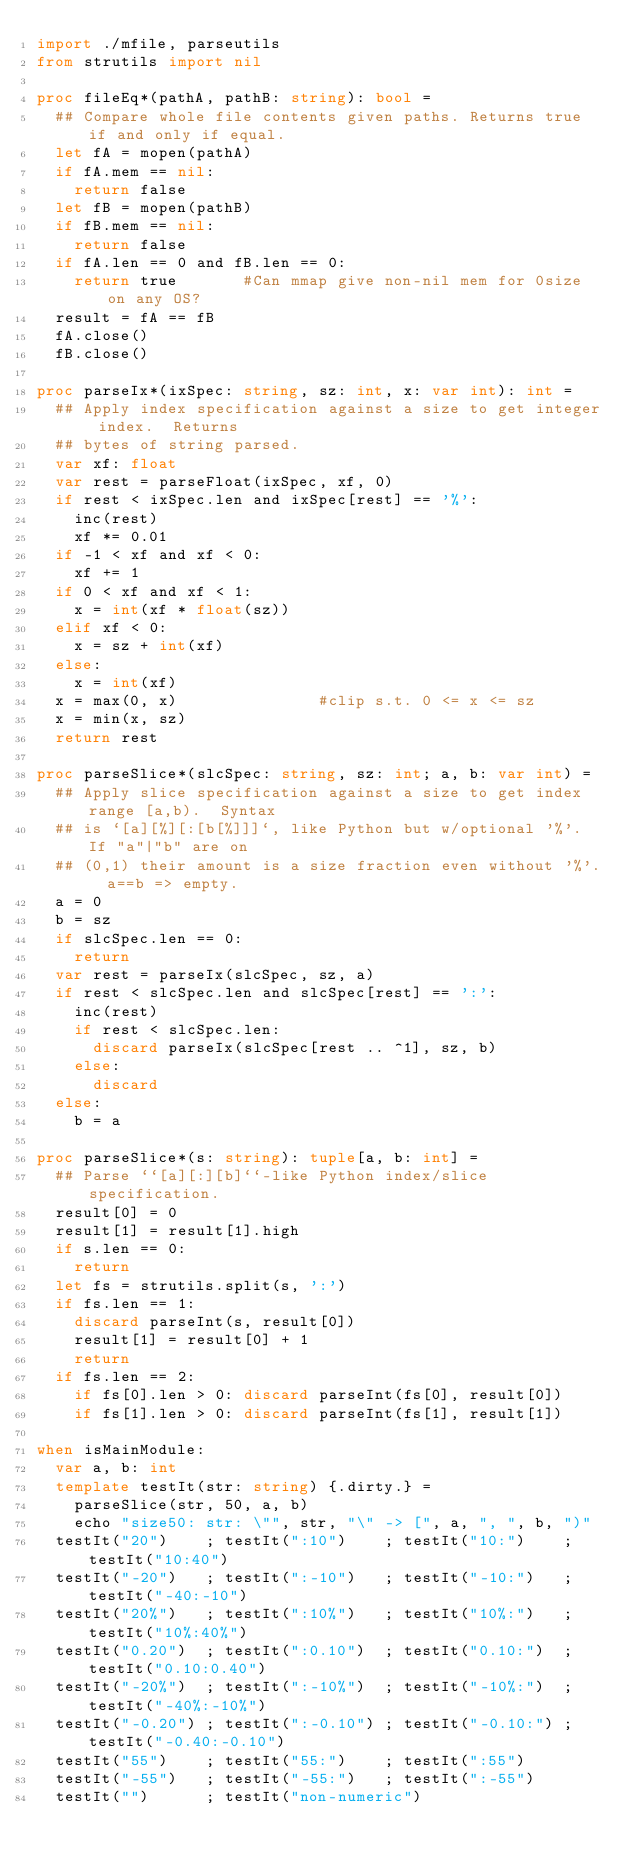Convert code to text. <code><loc_0><loc_0><loc_500><loc_500><_Nim_>import ./mfile, parseutils
from strutils import nil

proc fileEq*(pathA, pathB: string): bool =
  ## Compare whole file contents given paths. Returns true if and only if equal.
  let fA = mopen(pathA)
  if fA.mem == nil:
    return false
  let fB = mopen(pathB)
  if fB.mem == nil:
    return false
  if fA.len == 0 and fB.len == 0:
    return true       #Can mmap give non-nil mem for 0size on any OS?
  result = fA == fB
  fA.close()
  fB.close()

proc parseIx*(ixSpec: string, sz: int, x: var int): int =
  ## Apply index specification against a size to get integer index.  Returns
  ## bytes of string parsed.
  var xf: float
  var rest = parseFloat(ixSpec, xf, 0)
  if rest < ixSpec.len and ixSpec[rest] == '%':
    inc(rest)
    xf *= 0.01
  if -1 < xf and xf < 0:
    xf += 1
  if 0 < xf and xf < 1:
    x = int(xf * float(sz))
  elif xf < 0:
    x = sz + int(xf)
  else:
    x = int(xf)
  x = max(0, x)               #clip s.t. 0 <= x <= sz
  x = min(x, sz)
  return rest

proc parseSlice*(slcSpec: string, sz: int; a, b: var int) =
  ## Apply slice specification against a size to get index range [a,b).  Syntax
  ## is `[a][%][:[b[%]]]`, like Python but w/optional '%'.  If "a"|"b" are on
  ## (0,1) their amount is a size fraction even without '%'.  a==b => empty.
  a = 0
  b = sz
  if slcSpec.len == 0:
    return
  var rest = parseIx(slcSpec, sz, a)
  if rest < slcSpec.len and slcSpec[rest] == ':':
    inc(rest)
    if rest < slcSpec.len:
      discard parseIx(slcSpec[rest .. ^1], sz, b)
    else:
      discard
  else:
    b = a

proc parseSlice*(s: string): tuple[a, b: int] =
  ## Parse ``[a][:][b]``-like Python index/slice specification.
  result[0] = 0
  result[1] = result[1].high
  if s.len == 0:
    return
  let fs = strutils.split(s, ':')
  if fs.len == 1:
    discard parseInt(s, result[0])
    result[1] = result[0] + 1
    return
  if fs.len == 2:
    if fs[0].len > 0: discard parseInt(fs[0], result[0])
    if fs[1].len > 0: discard parseInt(fs[1], result[1])

when isMainModule:
  var a, b: int
  template testIt(str: string) {.dirty.} =
    parseSlice(str, 50, a, b)
    echo "size50: str: \"", str, "\" -> [", a, ", ", b, ")"
  testIt("20")    ; testIt(":10")    ; testIt("10:")    ; testIt("10:40")
  testIt("-20")   ; testIt(":-10")   ; testIt("-10:")   ; testIt("-40:-10")
  testIt("20%")   ; testIt(":10%")   ; testIt("10%:")   ; testIt("10%:40%")
  testIt("0.20")  ; testIt(":0.10")  ; testIt("0.10:")  ; testIt("0.10:0.40")
  testIt("-20%")  ; testIt(":-10%")  ; testIt("-10%:")  ; testIt("-40%:-10%")
  testIt("-0.20") ; testIt(":-0.10") ; testIt("-0.10:") ; testIt("-0.40:-0.10")
  testIt("55")    ; testIt("55:")    ; testIt(":55")
  testIt("-55")   ; testIt("-55:")   ; testIt(":-55")
  testIt("")      ; testIt("non-numeric")
</code> 